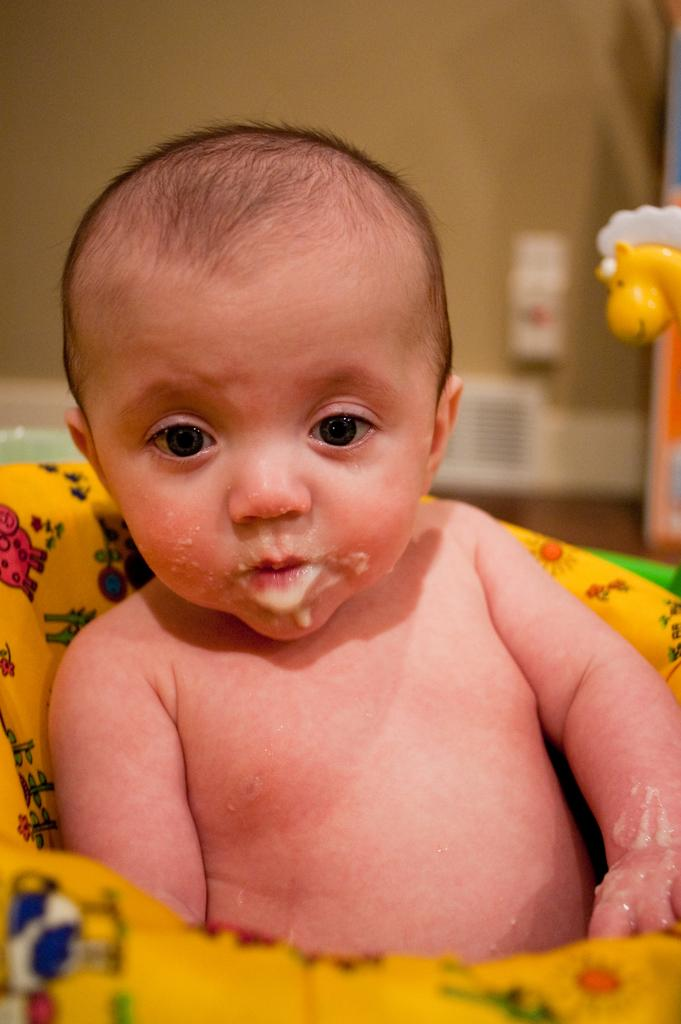What is the main subject of the image? There is a baby in the image. How is the baby dressed or covered in the image? The baby is wrapped in a yellow cloth. Are there any other objects or figures in the image? Yes, there is a yellow doll on the right side of the image. What type of stone can be seen in the image? There is no stone present in the image. Can you describe the kitty that is playing with the baby in the image? There is no kitty present in the image; it only features a baby wrapped in a yellow cloth and a yellow doll on the right side. 